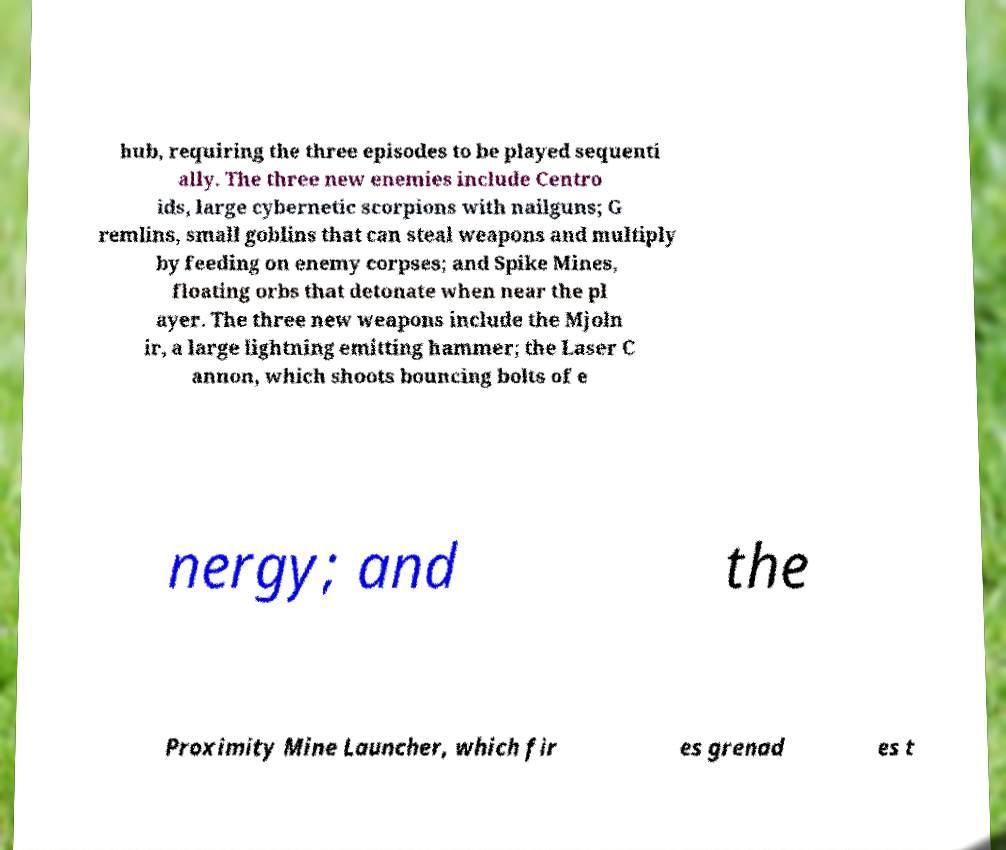Could you assist in decoding the text presented in this image and type it out clearly? hub, requiring the three episodes to be played sequenti ally. The three new enemies include Centro ids, large cybernetic scorpions with nailguns; G remlins, small goblins that can steal weapons and multiply by feeding on enemy corpses; and Spike Mines, floating orbs that detonate when near the pl ayer. The three new weapons include the Mjoln ir, a large lightning emitting hammer; the Laser C annon, which shoots bouncing bolts of e nergy; and the Proximity Mine Launcher, which fir es grenad es t 